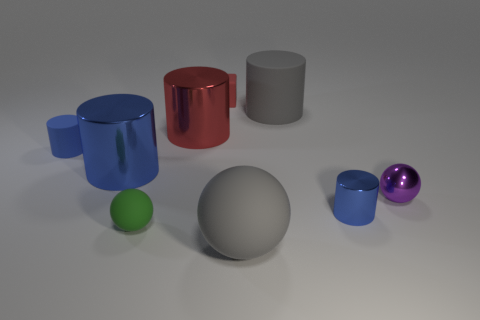Do the big blue cylinder and the large red object have the same material?
Ensure brevity in your answer.  Yes. Are there more large cylinders that are to the right of the big red object than small cyan rubber cylinders?
Ensure brevity in your answer.  Yes. What is the material of the ball on the left side of the small block that is on the right side of the metallic thing that is behind the tiny blue rubber cylinder?
Provide a succinct answer. Rubber. How many objects are either tiny blue shiny cylinders or rubber spheres that are on the left side of the big ball?
Offer a very short reply. 2. Do the large matte object behind the purple shiny object and the big ball have the same color?
Your response must be concise. Yes. Are there more small blue matte things that are to the right of the tiny rubber block than green balls to the left of the large rubber sphere?
Offer a very short reply. No. Is there anything else of the same color as the shiny ball?
Ensure brevity in your answer.  No. What number of objects are either blue metallic objects or large brown metallic blocks?
Your answer should be compact. 2. There is a metallic object that is in front of the purple sphere; does it have the same size as the purple object?
Give a very brief answer. Yes. How many other things are there of the same size as the blue matte thing?
Your response must be concise. 4. 